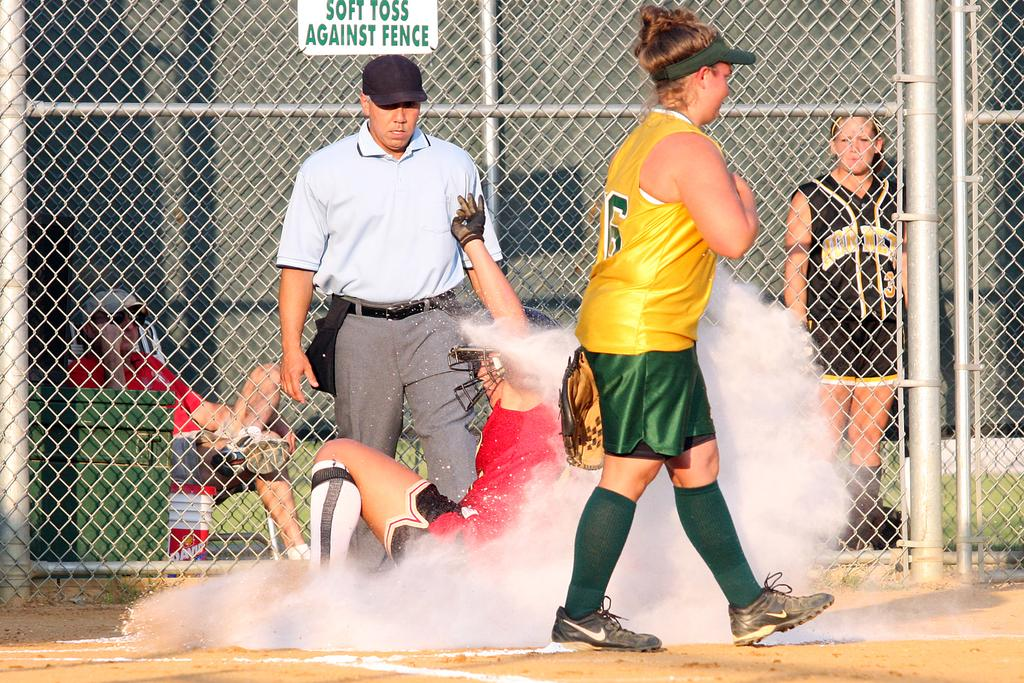<image>
Summarize the visual content of the image. A sign on the chain link fence says that people should soft toss against the fence. 